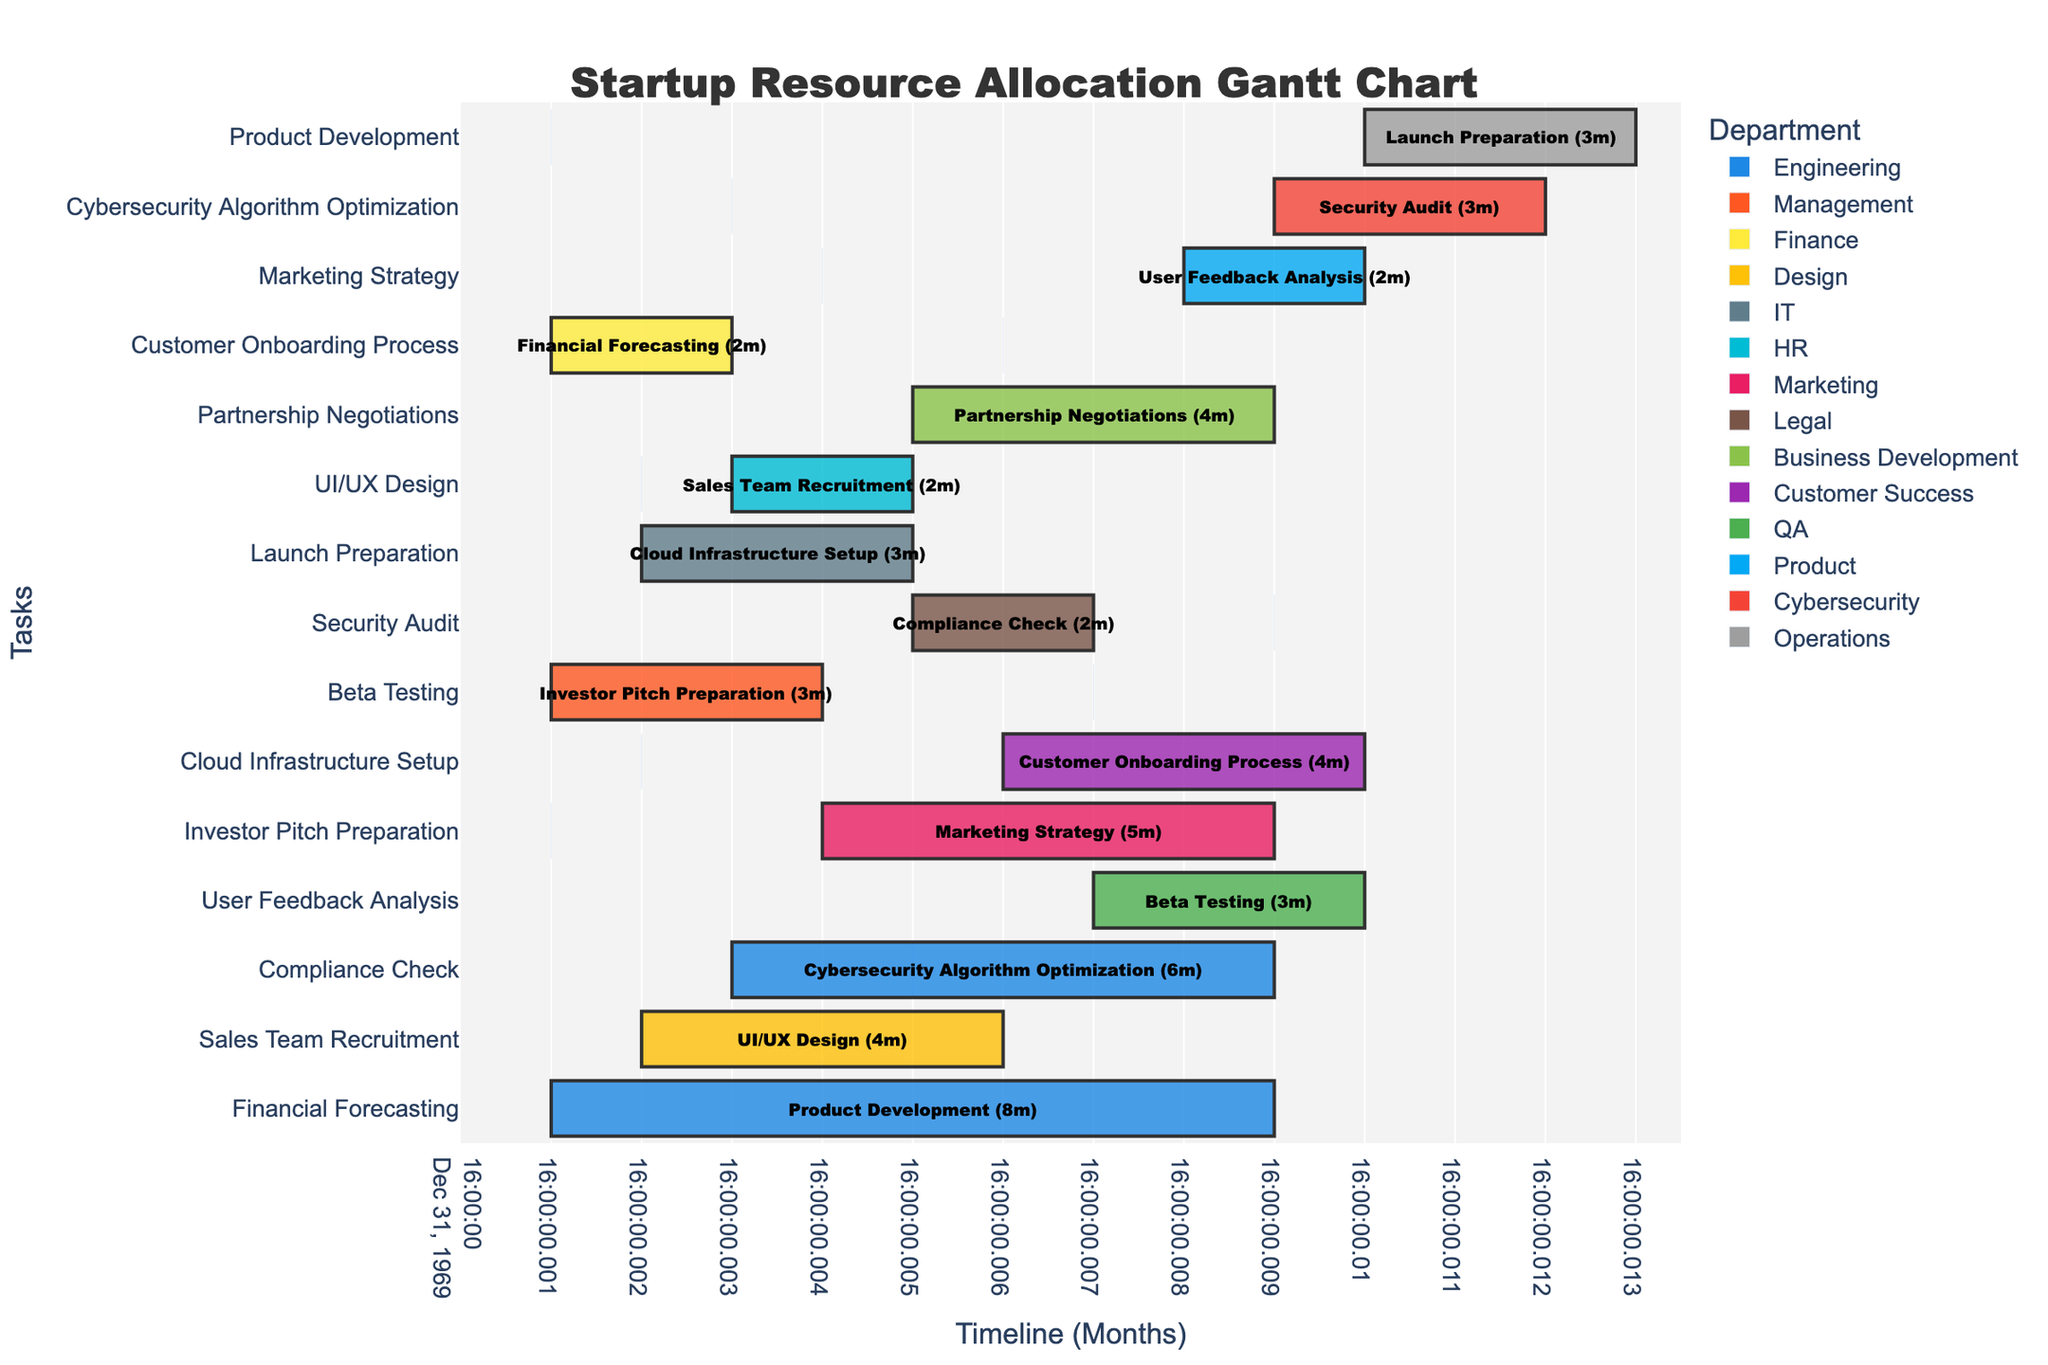Which department has the longest duration task? By looking at the Gantt chart, we see that the longest duration task is Product Development under the Engineering department with a duration of 8 months.
Answer: Engineering How many tasks are scheduled to start in the 3rd month? From the Gantt chart, we can see that the tasks "Cybersecurity Algorithm Optimization," "Sales Team Recruitment," and "Financial Forecasting" start in the 3rd month.
Answer: 3 Which task is completed the earliest, and when does it end? By examining the timeline, the "Investor Pitch Preparation" task from the Management department ends first, ending in the 4th month (starting from the 1st month and lasting 3 months).
Answer: Investor Pitch Preparation, in the 4th month Which task is exclusively scheduled for the Legal department, and what is its duration? The only task for the Legal department is "Compliance Check," which has a duration of 2 months as seen in the Gantt chart.
Answer: Compliance Check, 2 months Compare the durations of the "Beta Testing" and "Cloud Infrastructure Setup." Which one takes longer? "Beta Testing" takes 3 months whereas "Cloud Infrastructure Setup" takes 3 months as well. Therefore, they have equal durations.
Answer: Equal durations What is the total duration of all the Engineering department tasks combined? The Engineering department has two tasks: "Product Development" (8 months) and "Cybersecurity Algorithm Optimization" (6 months). Adding them, we get 8 + 6 = 14 months.
Answer: 14 months Which tasks overlap with "Marketing Strategy" in terms of their duration? Referring to the chart, "Customer Onboarding Process" (starts at month 6), "Compliance Check" (months 5-7), and "Partnership Negotiations" (months 5-9) overlap with "Marketing Strategy" (months 4-9).
Answer: Customer Onboarding Process, Compliance Check, Partnership Negotiations Are there any tasks that start at the same time as "Security Audit"? If yes, which ones? According to the Gantt chart, "Security Audit" starts in the 9th month. No other task starts in the 9th month.
Answer: No What's the shortest task duration depicted on the chart, and which task does it correspond to? The shortest task duration is 2 months. Tasks with 2 months are "Compliance Check," "Sales Team Recruitment," and "Financial Forecasting."
Answer: 2 months, Compliance Check/Sales Team Recruitment/Financial Forecasting 